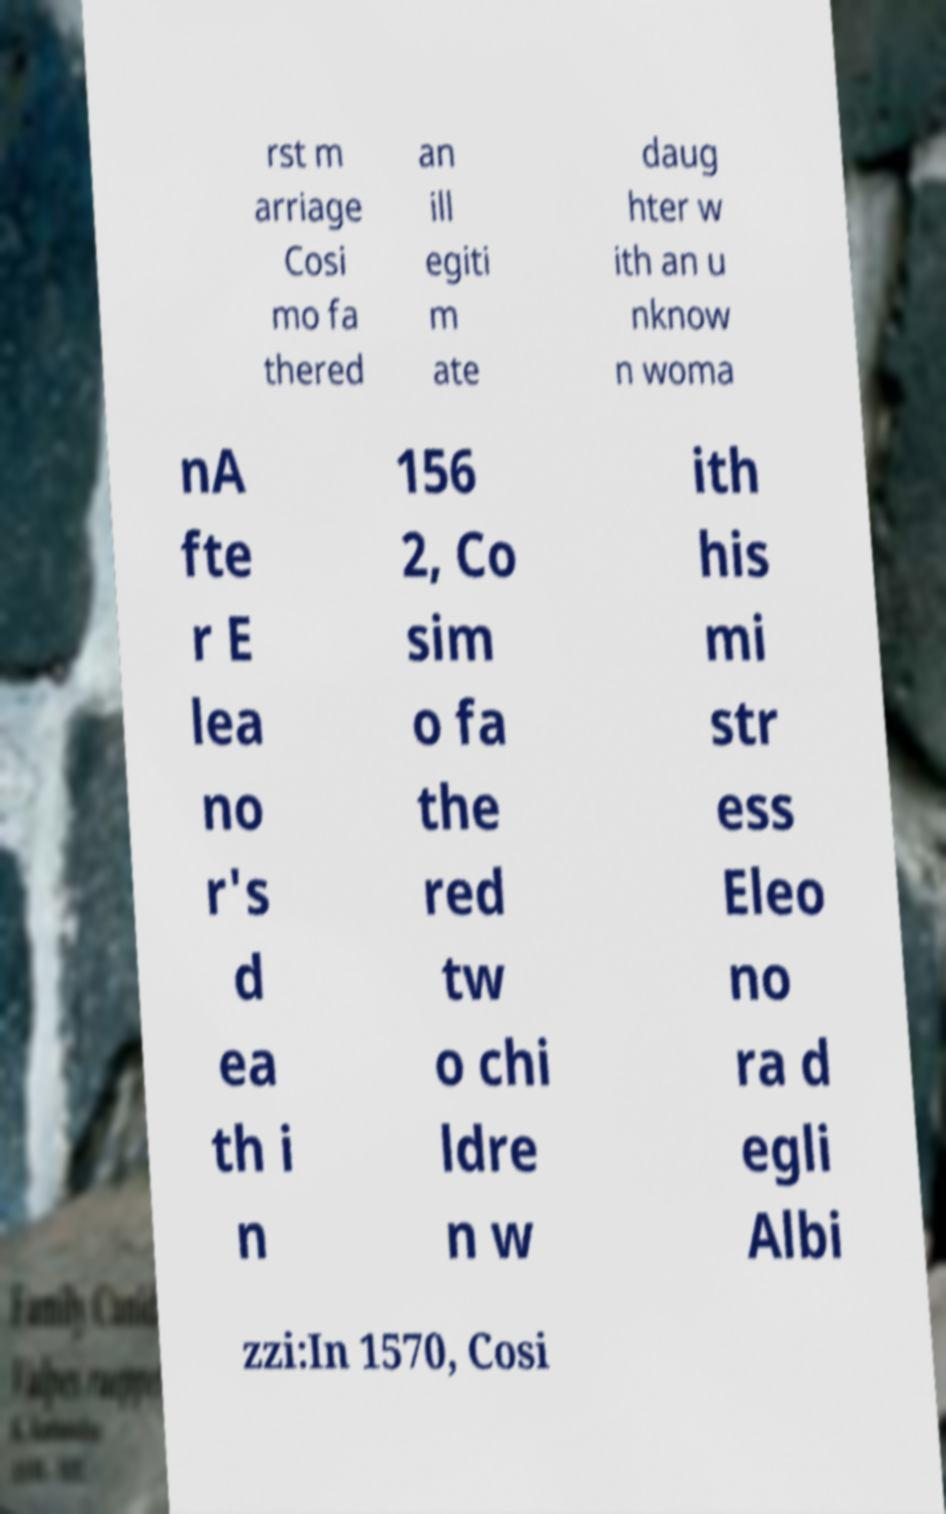Can you read and provide the text displayed in the image?This photo seems to have some interesting text. Can you extract and type it out for me? rst m arriage Cosi mo fa thered an ill egiti m ate daug hter w ith an u nknow n woma nA fte r E lea no r's d ea th i n 156 2, Co sim o fa the red tw o chi ldre n w ith his mi str ess Eleo no ra d egli Albi zzi:In 1570, Cosi 